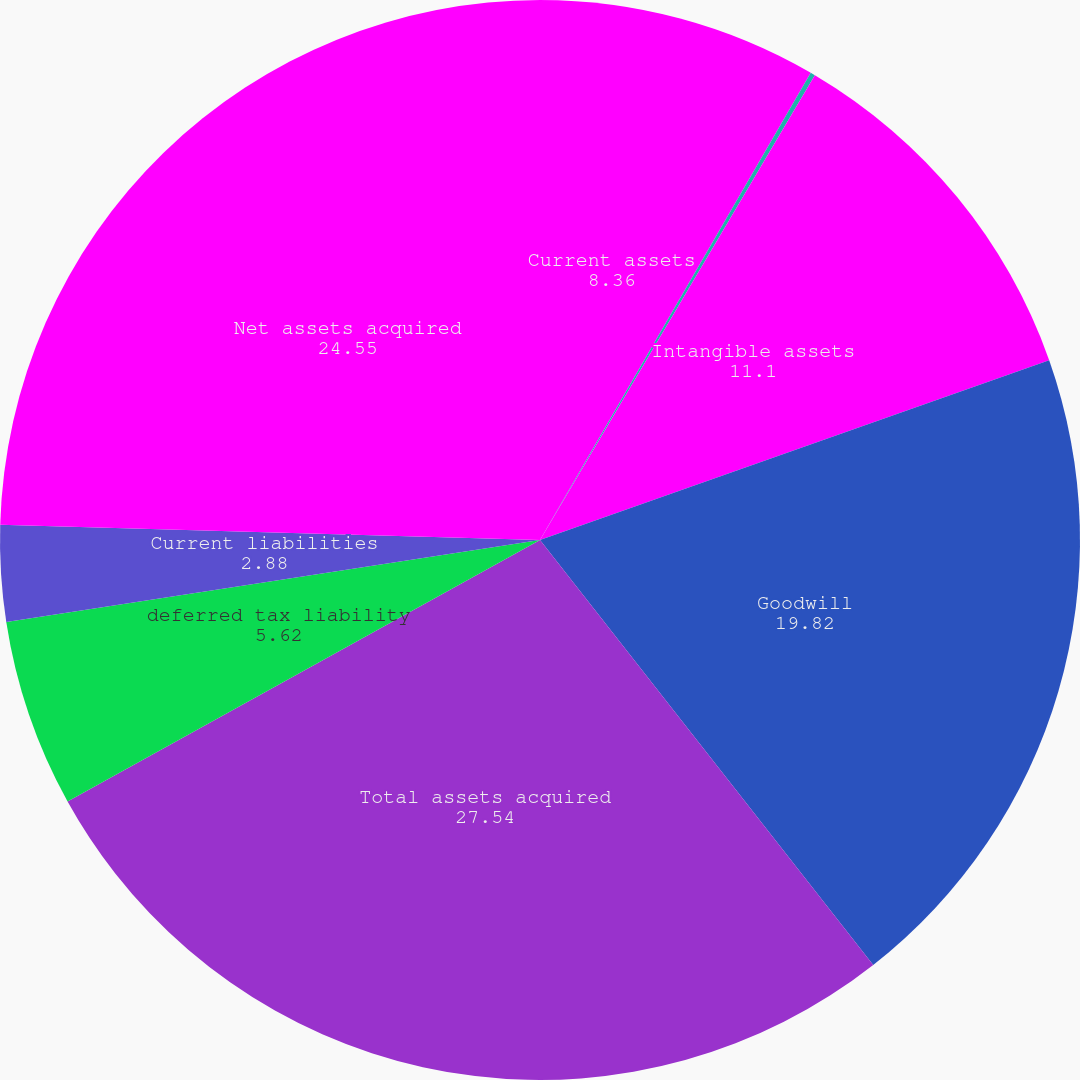<chart> <loc_0><loc_0><loc_500><loc_500><pie_chart><fcel>Current assets<fcel>Property and equipment<fcel>Intangible assets<fcel>Goodwill<fcel>Total assets acquired<fcel>deferred tax liability<fcel>Current liabilities<fcel>Net assets acquired<nl><fcel>8.36%<fcel>0.14%<fcel>11.1%<fcel>19.82%<fcel>27.54%<fcel>5.62%<fcel>2.88%<fcel>24.55%<nl></chart> 